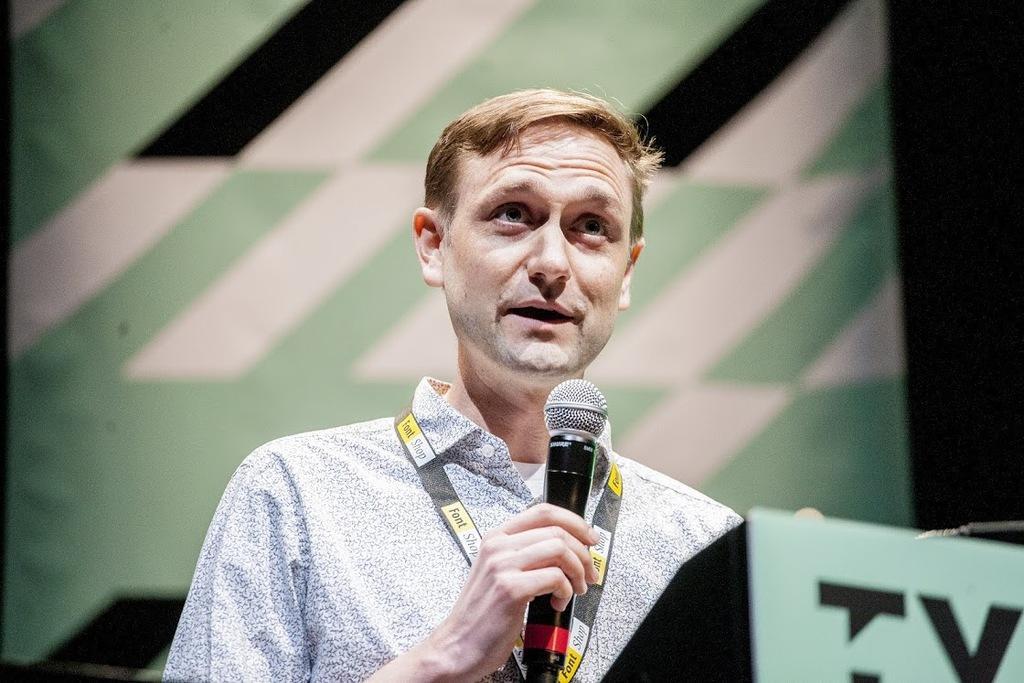Describe this image in one or two sentences. This image is clicked in a conference. In this image, there is a man standing behind the podium and talking in the mic. He is wearing a white shirt. In the background, there is a banner in green color. 